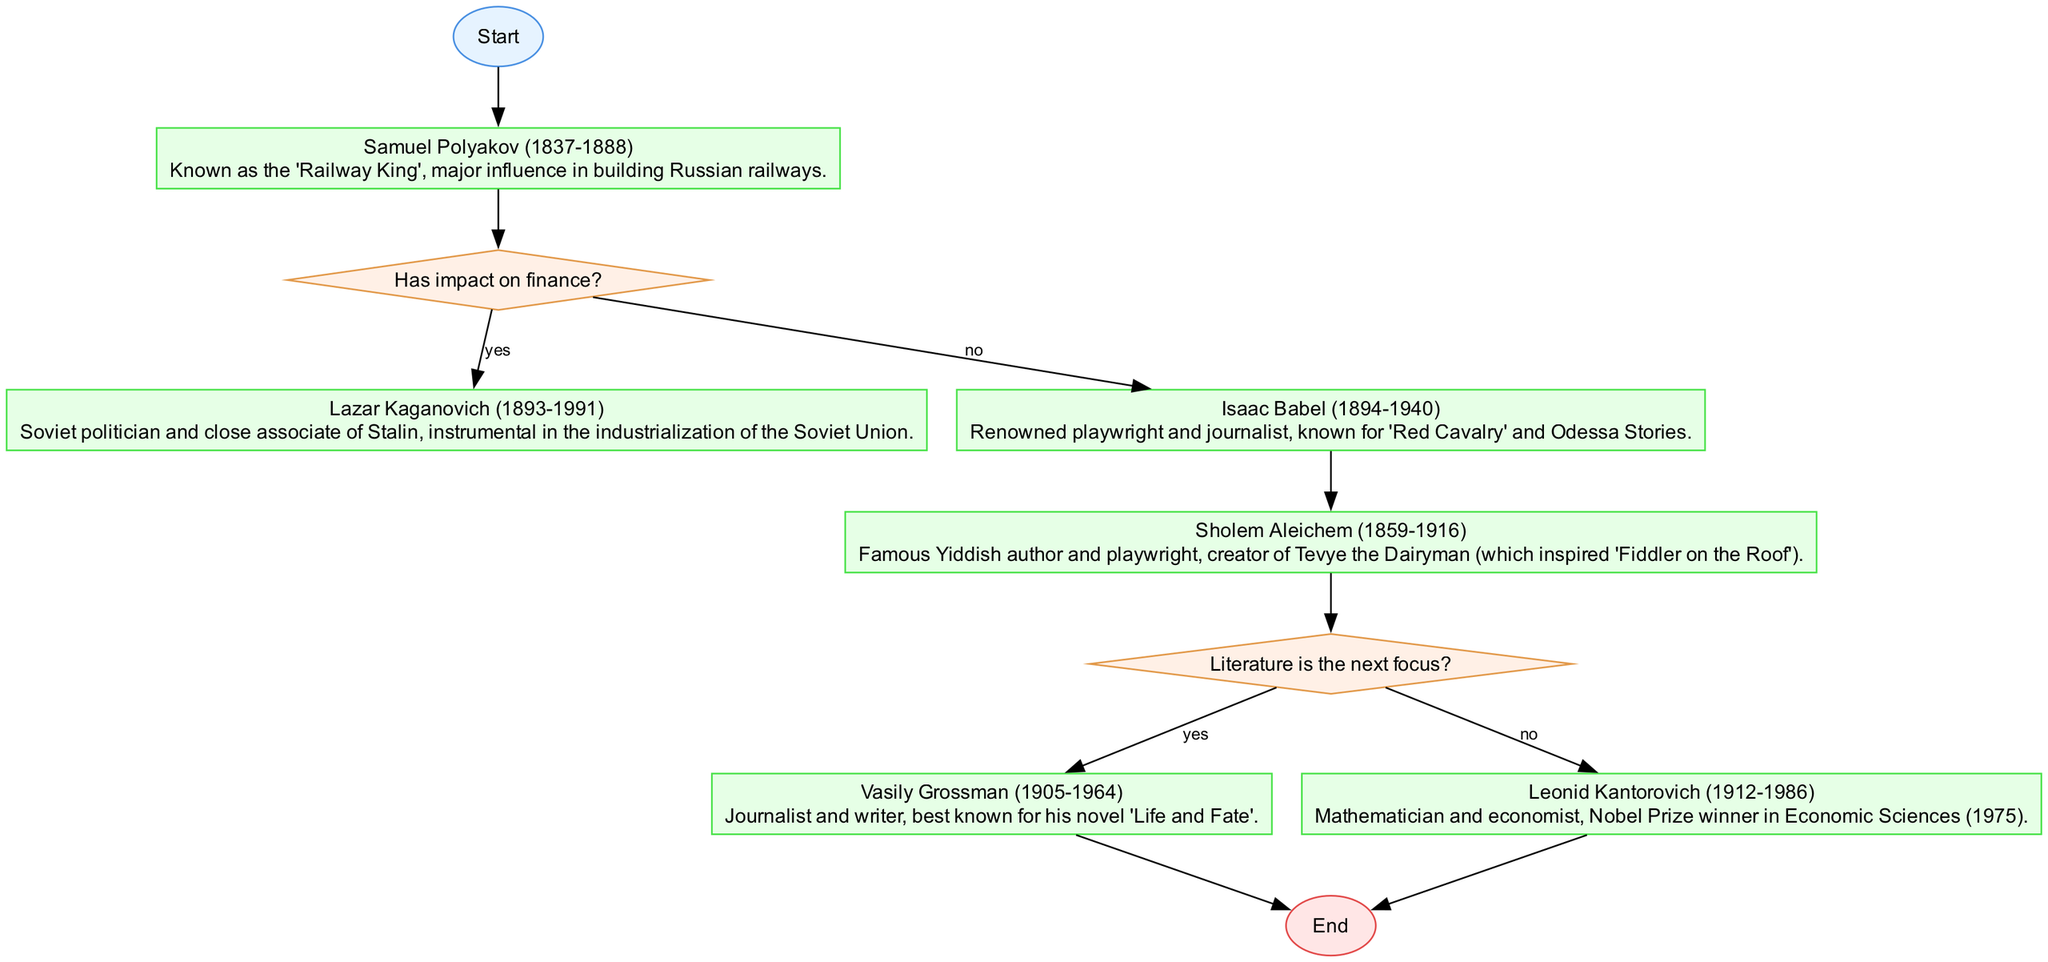What is the first notable Jewish personality mentioned in the flowchart? The flowchart starts at the "Start" node and proceeds to "Samuel Polyakov (1837-1888)", which is the first personality listed.
Answer: Samuel Polyakov (1837-1888) How many decision nodes are present in the diagram? By reviewing the diagram, there are two decision nodes: "Has impact on finance?" and "Literature is the next focus?"
Answer: 2 Which personality is associated with industrialization in the Soviet Union? The flow progresses from "Samuel Polyakov" to the decision node about financial impact, leading to "Lazar Kaganovich (1893-1991)", who is identified as instrumental in industrialization.
Answer: Lazar Kaganovich (1893-1991) What happens if the literature is the next focus? Following the flow from "Sholem Aleichem (1859-1916)" to the decision node "Literature is the next focus?", if the answer is 'yes', the flow goes to "Vasily Grossman (1905-1964)".
Answer: Vasily Grossman (1905-1964) Who is depicted as a Nobel Prize winner in this genealogy flowchart? Starting from the last decision node, if the focus is not on literature, the flow leads to "Leonid Kantorovich (1912-1986)", who is identified as a Nobel Prize winner.
Answer: Leonid Kantorovich (1912-1986) What notable work is Isaac Babel known for? According to the flowchart, "Isaac Babel (1894-1940)" is noted for his contributions as a playwright and journalist, with specific mention of "Red Cavalry" and "Odessa Stories."
Answer: Red Cavalry Which node follows after a 'no' response from the decision regarding financial impact? In the flowchart, after the 'no' response to "Has impact on finance?", the next node is "Isaac Babel (1894-1940)".
Answer: Isaac Babel (1894-1940) What is the final node in the flowchart? The flowchart concludes with the "End" node, which appears after finalizing the pathways to both "Vasily Grossman" and "Leonid Kantorovich".
Answer: End 